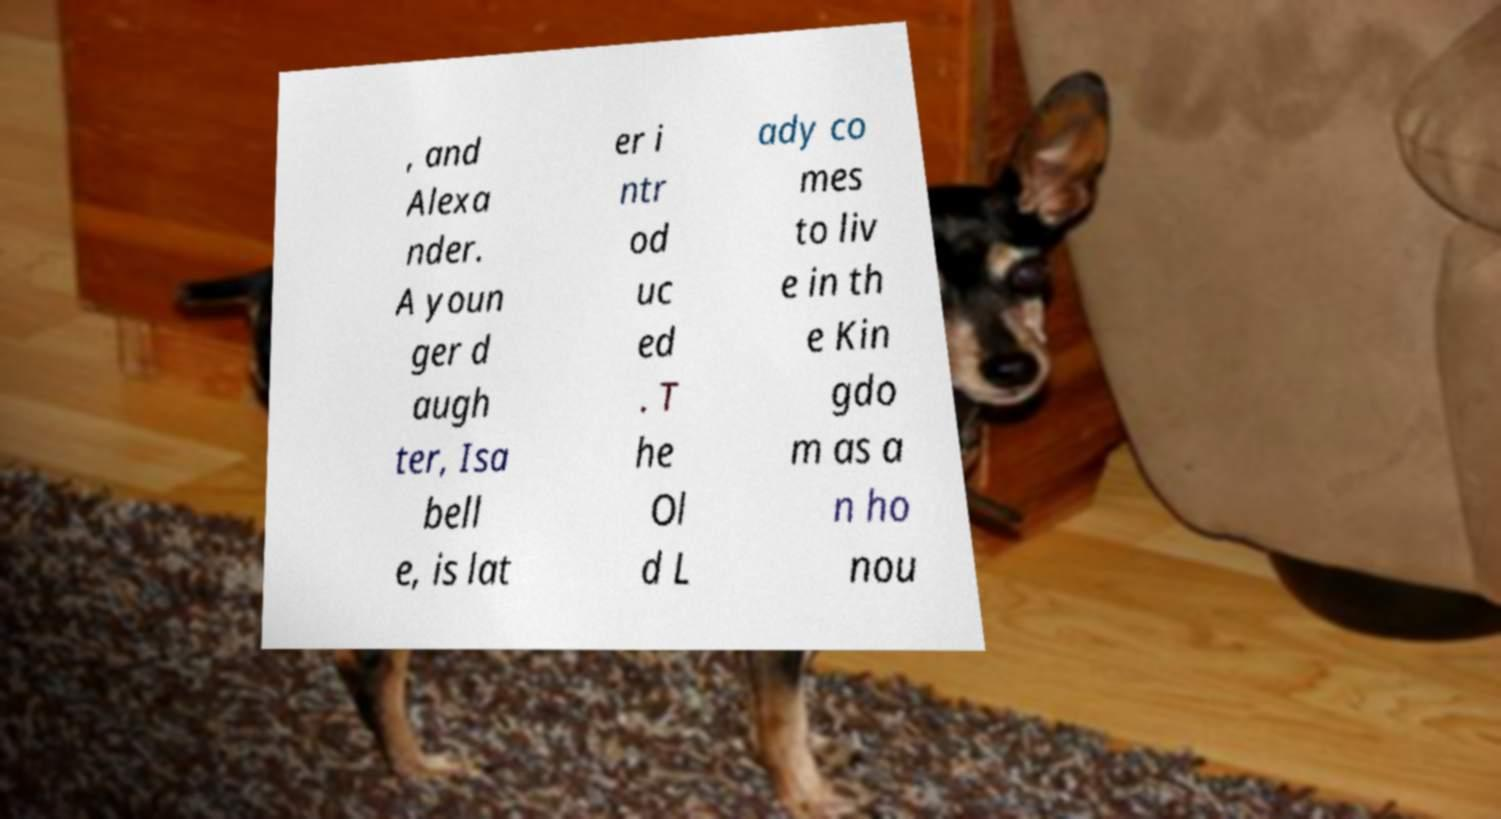Can you accurately transcribe the text from the provided image for me? , and Alexa nder. A youn ger d augh ter, Isa bell e, is lat er i ntr od uc ed . T he Ol d L ady co mes to liv e in th e Kin gdo m as a n ho nou 